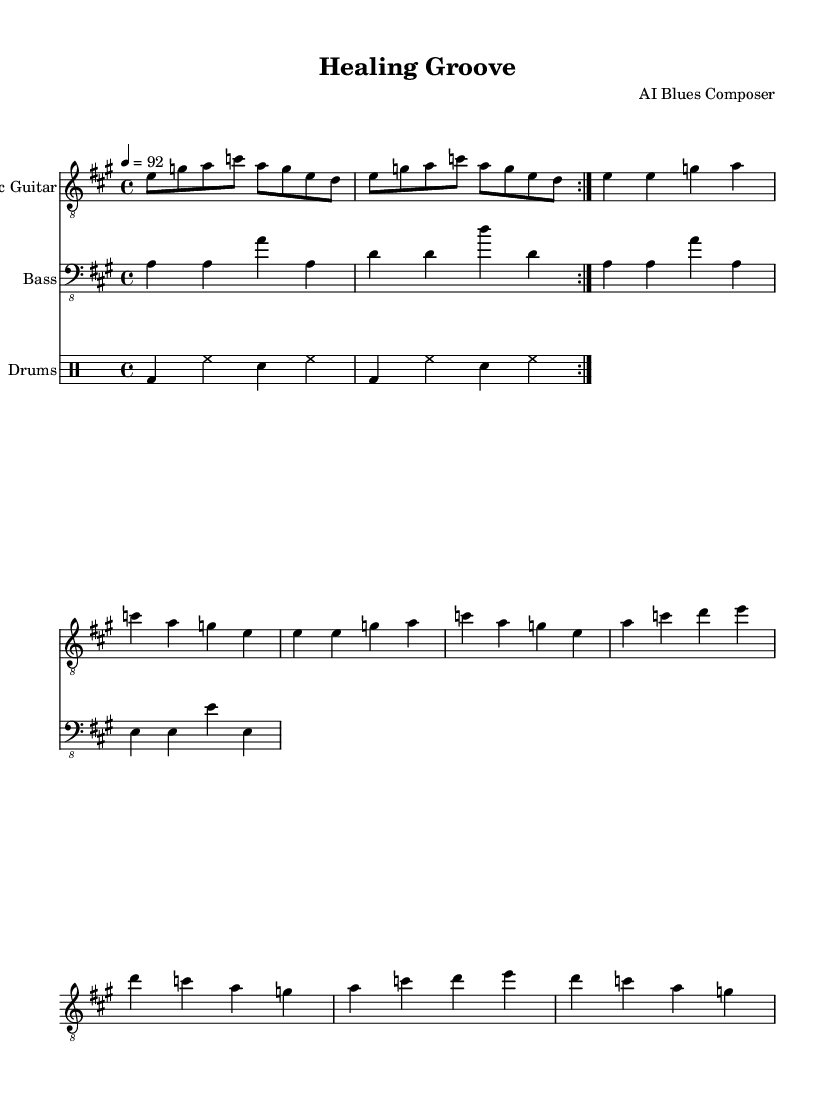What is the key signature of this music? The key signature is A major, which contains three sharps (F#, C#, and G#) represented in the music sheet by the sharp symbols at the beginning.
Answer: A major What is the time signature of the piece? The time signature is 4/4, which is indicated at the beginning of the score. This means there are 4 beats in every measure.
Answer: 4/4 What is the tempo marking of the piece? The tempo marking is indicated as "4 = 92," meaning the piece should be played at a speed of 92 beats per minute, with each quarter note getting one beat.
Answer: 92 How many measures are in the verses? The verses contain a total of 8 measures, as there are 4 measures listed, and they are repeated once.
Answer: 8 In which section does the electric guitar have a repeated riff? The electric guitar's riff is repeated in the intro section, indicated by the \repeat volta command, which specifies two repeats of the measures that follow it.
Answer: Intro What type of rhythm is commonly used in Electric Blues? Electric Blues typically uses a shuffle or swing rhythm, which is characterized by a swung eighth-note feel, although this piece appears to utilize a straight rhythm instead, aligning with a more straightforward rock-blues feel.
Answer: Shuffle (or straight rhythm) What instrument plays the bass line in this piece? The bass line is played by the bass guitar, which is indicated by the staff labeled "Bass" in the score.
Answer: Bass guitar 